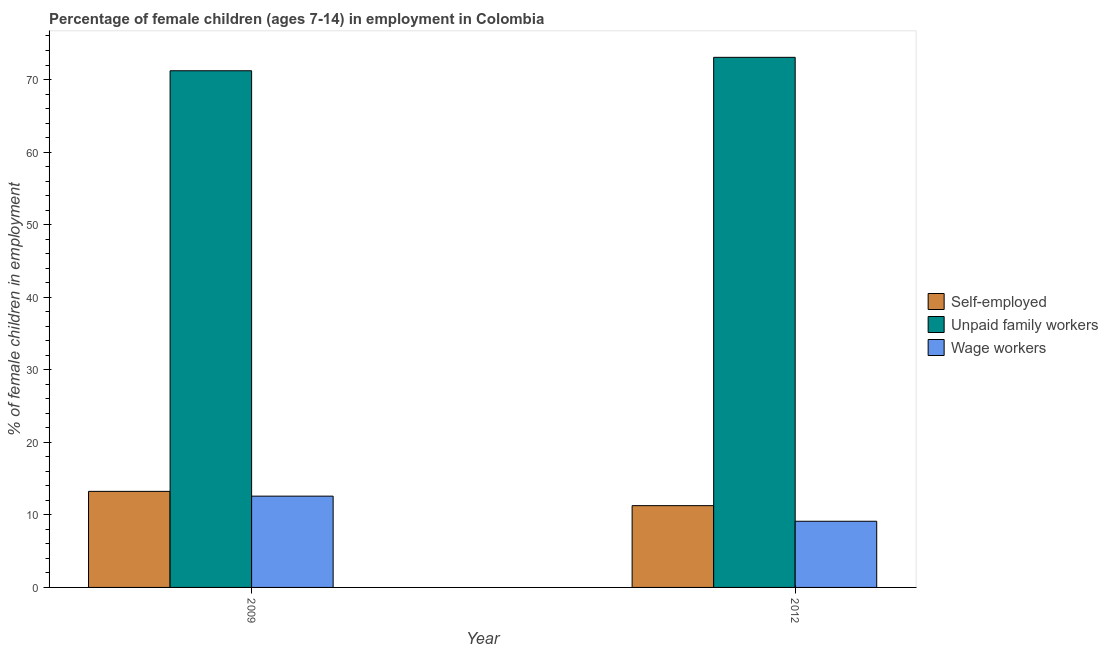How many different coloured bars are there?
Provide a short and direct response. 3. Are the number of bars per tick equal to the number of legend labels?
Provide a short and direct response. Yes. How many bars are there on the 1st tick from the right?
Offer a very short reply. 3. What is the percentage of children employed as unpaid family workers in 2012?
Your answer should be compact. 73.06. Across all years, what is the maximum percentage of children employed as unpaid family workers?
Provide a succinct answer. 73.06. Across all years, what is the minimum percentage of children employed as wage workers?
Ensure brevity in your answer.  9.12. What is the total percentage of children employed as unpaid family workers in the graph?
Ensure brevity in your answer.  144.27. What is the difference between the percentage of self employed children in 2009 and that in 2012?
Give a very brief answer. 1.97. What is the difference between the percentage of children employed as wage workers in 2009 and the percentage of self employed children in 2012?
Provide a succinct answer. 3.46. What is the average percentage of self employed children per year?
Offer a terse response. 12.25. In the year 2012, what is the difference between the percentage of self employed children and percentage of children employed as unpaid family workers?
Make the answer very short. 0. What is the ratio of the percentage of children employed as wage workers in 2009 to that in 2012?
Provide a short and direct response. 1.38. Is the percentage of self employed children in 2009 less than that in 2012?
Offer a very short reply. No. What does the 3rd bar from the left in 2012 represents?
Ensure brevity in your answer.  Wage workers. What does the 2nd bar from the right in 2009 represents?
Make the answer very short. Unpaid family workers. How many years are there in the graph?
Keep it short and to the point. 2. Are the values on the major ticks of Y-axis written in scientific E-notation?
Ensure brevity in your answer.  No. Does the graph contain any zero values?
Provide a succinct answer. No. Does the graph contain grids?
Make the answer very short. No. How are the legend labels stacked?
Give a very brief answer. Vertical. What is the title of the graph?
Your answer should be very brief. Percentage of female children (ages 7-14) in employment in Colombia. What is the label or title of the Y-axis?
Your answer should be very brief. % of female children in employment. What is the % of female children in employment of Self-employed in 2009?
Provide a short and direct response. 13.24. What is the % of female children in employment in Unpaid family workers in 2009?
Your response must be concise. 71.21. What is the % of female children in employment of Wage workers in 2009?
Keep it short and to the point. 12.58. What is the % of female children in employment of Self-employed in 2012?
Provide a short and direct response. 11.27. What is the % of female children in employment in Unpaid family workers in 2012?
Offer a very short reply. 73.06. What is the % of female children in employment in Wage workers in 2012?
Ensure brevity in your answer.  9.12. Across all years, what is the maximum % of female children in employment of Self-employed?
Your response must be concise. 13.24. Across all years, what is the maximum % of female children in employment of Unpaid family workers?
Offer a very short reply. 73.06. Across all years, what is the maximum % of female children in employment in Wage workers?
Your answer should be very brief. 12.58. Across all years, what is the minimum % of female children in employment of Self-employed?
Your response must be concise. 11.27. Across all years, what is the minimum % of female children in employment of Unpaid family workers?
Offer a terse response. 71.21. Across all years, what is the minimum % of female children in employment in Wage workers?
Ensure brevity in your answer.  9.12. What is the total % of female children in employment in Self-employed in the graph?
Offer a very short reply. 24.51. What is the total % of female children in employment in Unpaid family workers in the graph?
Give a very brief answer. 144.27. What is the total % of female children in employment in Wage workers in the graph?
Your answer should be very brief. 21.7. What is the difference between the % of female children in employment of Self-employed in 2009 and that in 2012?
Offer a terse response. 1.97. What is the difference between the % of female children in employment in Unpaid family workers in 2009 and that in 2012?
Your answer should be compact. -1.85. What is the difference between the % of female children in employment of Wage workers in 2009 and that in 2012?
Make the answer very short. 3.46. What is the difference between the % of female children in employment of Self-employed in 2009 and the % of female children in employment of Unpaid family workers in 2012?
Offer a very short reply. -59.82. What is the difference between the % of female children in employment in Self-employed in 2009 and the % of female children in employment in Wage workers in 2012?
Ensure brevity in your answer.  4.12. What is the difference between the % of female children in employment of Unpaid family workers in 2009 and the % of female children in employment of Wage workers in 2012?
Give a very brief answer. 62.09. What is the average % of female children in employment of Self-employed per year?
Offer a very short reply. 12.26. What is the average % of female children in employment in Unpaid family workers per year?
Keep it short and to the point. 72.14. What is the average % of female children in employment of Wage workers per year?
Offer a very short reply. 10.85. In the year 2009, what is the difference between the % of female children in employment in Self-employed and % of female children in employment in Unpaid family workers?
Your answer should be very brief. -57.97. In the year 2009, what is the difference between the % of female children in employment in Self-employed and % of female children in employment in Wage workers?
Make the answer very short. 0.66. In the year 2009, what is the difference between the % of female children in employment of Unpaid family workers and % of female children in employment of Wage workers?
Offer a very short reply. 58.63. In the year 2012, what is the difference between the % of female children in employment of Self-employed and % of female children in employment of Unpaid family workers?
Provide a succinct answer. -61.79. In the year 2012, what is the difference between the % of female children in employment of Self-employed and % of female children in employment of Wage workers?
Your answer should be very brief. 2.15. In the year 2012, what is the difference between the % of female children in employment in Unpaid family workers and % of female children in employment in Wage workers?
Your response must be concise. 63.94. What is the ratio of the % of female children in employment in Self-employed in 2009 to that in 2012?
Your answer should be compact. 1.17. What is the ratio of the % of female children in employment of Unpaid family workers in 2009 to that in 2012?
Keep it short and to the point. 0.97. What is the ratio of the % of female children in employment in Wage workers in 2009 to that in 2012?
Ensure brevity in your answer.  1.38. What is the difference between the highest and the second highest % of female children in employment in Self-employed?
Provide a succinct answer. 1.97. What is the difference between the highest and the second highest % of female children in employment in Unpaid family workers?
Your response must be concise. 1.85. What is the difference between the highest and the second highest % of female children in employment in Wage workers?
Your response must be concise. 3.46. What is the difference between the highest and the lowest % of female children in employment of Self-employed?
Provide a short and direct response. 1.97. What is the difference between the highest and the lowest % of female children in employment of Unpaid family workers?
Offer a terse response. 1.85. What is the difference between the highest and the lowest % of female children in employment in Wage workers?
Keep it short and to the point. 3.46. 